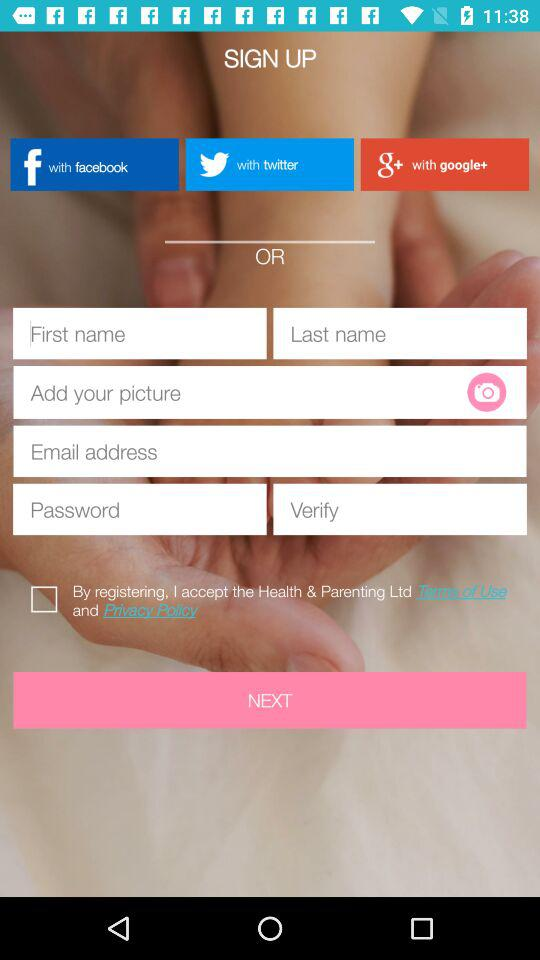Through which application can we sign up? You can sign up through "facebook", "twitter" and "google+". 